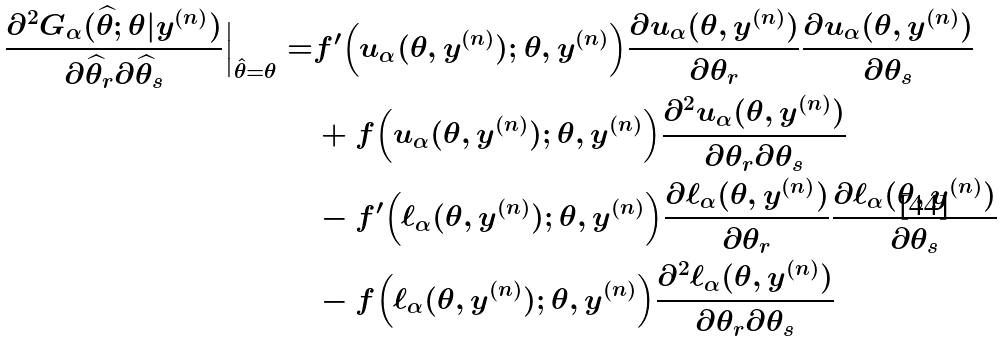<formula> <loc_0><loc_0><loc_500><loc_500>\frac { \partial ^ { 2 } G _ { \alpha } ( \widehat { \theta } ; \theta | y ^ { ( n ) } ) } { \partial \widehat { \theta } _ { r } \partial \widehat { \theta } _ { s } } \Big | _ { \hat { \theta } = \theta } = & f ^ { \prime } \Big ( u _ { \alpha } ( \theta , y ^ { ( n ) } ) ; \theta , y ^ { ( n ) } \Big ) \frac { \partial u _ { \alpha } ( \theta , y ^ { ( n ) } ) } { \partial \theta _ { r } } \frac { \partial u _ { \alpha } ( \theta , y ^ { ( n ) } ) } { \partial \theta _ { s } } \\ & + f \Big ( u _ { \alpha } ( \theta , y ^ { ( n ) } ) ; \theta , y ^ { ( n ) } \Big ) \frac { \partial ^ { 2 } u _ { \alpha } ( \theta , y ^ { ( n ) } ) } { \partial \theta _ { r } \partial \theta _ { s } } \\ & - f ^ { \prime } \Big ( \ell _ { \alpha } ( \theta , y ^ { ( n ) } ) ; \theta , y ^ { ( n ) } \Big ) \frac { \partial \ell _ { \alpha } ( \theta , y ^ { ( n ) } ) } { \partial \theta _ { r } } \frac { \partial \ell _ { \alpha } ( \theta , y ^ { ( n ) } ) } { \partial \theta _ { s } } \\ & - f \Big ( \ell _ { \alpha } ( \theta , y ^ { ( n ) } ) ; \theta , y ^ { ( n ) } \Big ) \frac { \partial ^ { 2 } \ell _ { \alpha } ( \theta , y ^ { ( n ) } ) } { \partial \theta _ { r } \partial \theta _ { s } }</formula> 